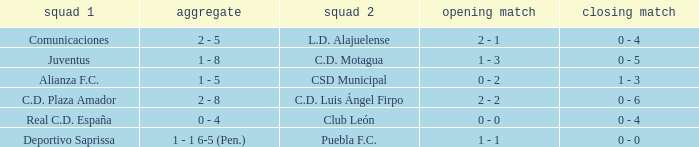What is the 1st leg where Team 1 is C.D. Plaza Amador? 2 - 2. 